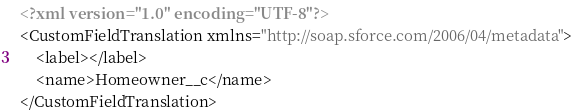Convert code to text. <code><loc_0><loc_0><loc_500><loc_500><_XML_><?xml version="1.0" encoding="UTF-8"?>
<CustomFieldTranslation xmlns="http://soap.sforce.com/2006/04/metadata">
    <label></label>
    <name>Homeowner__c</name>
</CustomFieldTranslation>
</code> 